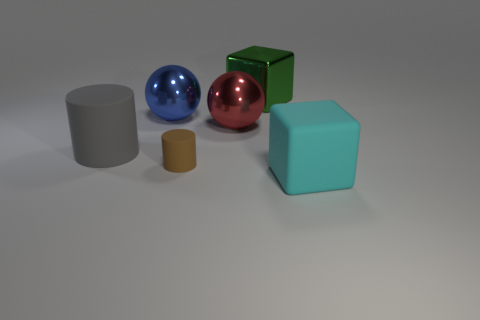Add 2 small red metal objects. How many objects exist? 8 Subtract all spheres. How many objects are left? 4 Add 1 large gray metal cylinders. How many large gray metal cylinders exist? 1 Subtract 1 blue spheres. How many objects are left? 5 Subtract all matte cylinders. Subtract all big blue objects. How many objects are left? 3 Add 4 big green metal cubes. How many big green metal cubes are left? 5 